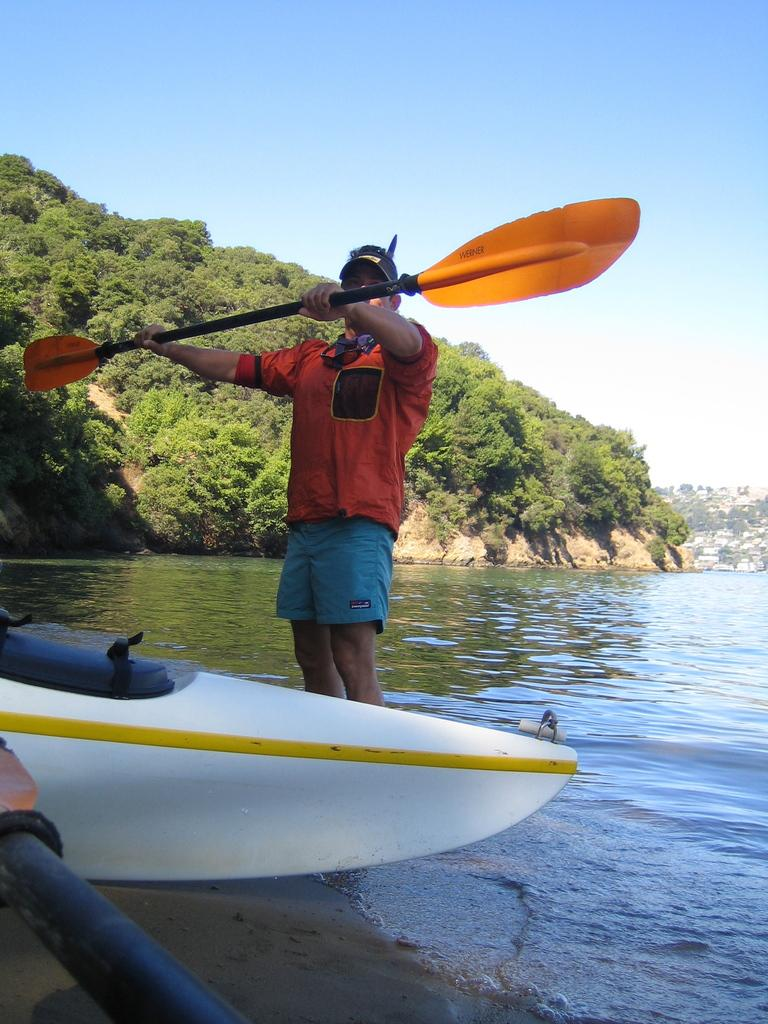What is the person in the image holding? The person is holding a paddle in the image. What is the condition of the boat in the image? The boat is on the ground in the image. What type of environment is visible in the image? There is water and trees visible in the image, suggesting a natural setting. What can be seen in the sky in the image? The sky is visible in the background of the image. What is the title of the dog in the image? There is no dog present in the image, so there is no title to be given. 